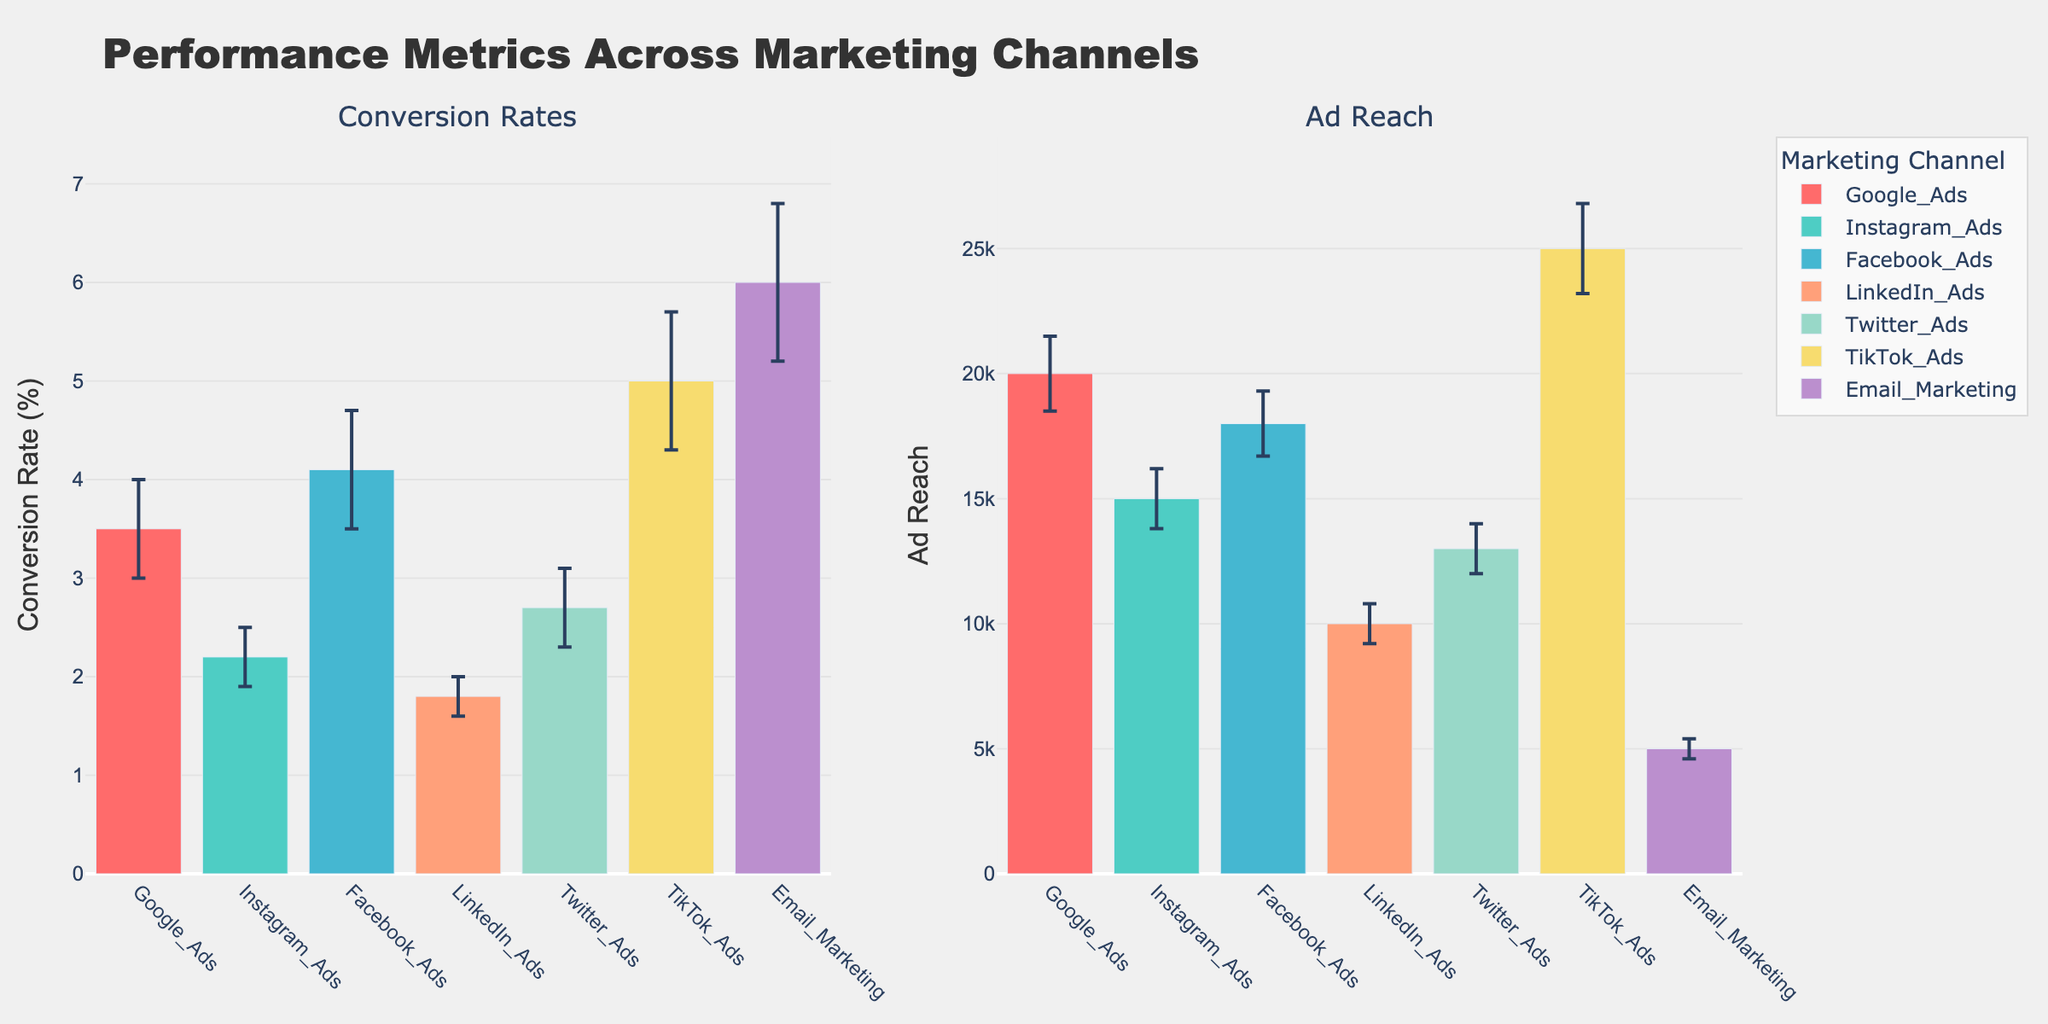What are the titles of the subplots? The subplot titles are at the top of each subplot. The first subplot is titled "Conversion Rates," and the second subplot is titled "Ad Reach."
Answer: "Conversion Rates" and "Ad Reach" Which marketing channel has the highest conversion rate? By looking at the height of the bars in the "Conversion Rates" subplot, the bar for "Email Marketing" is the highest.
Answer: Email Marketing How much higher is TikTok Ads' ad reach compared to LinkedIn Ads' ad reach? TikTok Ads has an ad reach of 25000 with an error margin of 1800, and LinkedIn Ads has an ad reach of 10000 with an error margin of 800. The difference is 25000 - 10000 = 15000.
Answer: 15000 Which marketing channel has the lowest conversion rate? By comparing the heights of all bars in the "Conversion Rates" subplot, LinkedIn Ads has the lowest conversion rate.
Answer: LinkedIn Ads What is the error margin for Instagram Ads' conversion rate? The error margin is represented by the length of the error bar on top of the Instagram Ads bar in the "Conversion Rates" subplot. The error margin is 0.3%.
Answer: 0.3% Between Google Ads and Facebook Ads, which has a better performance in terms of conversion rate? By examining the bars in the "Conversion Rates" subplot, Facebook Ads has a higher conversion rate (4.1%) compared to Google Ads (3.5%).
Answer: Facebook Ads Does any marketing channel have an ad reach below 10,000? By reviewing the "Ad Reach" subplot, Email Marketing has an ad reach below 10,000.
Answer: Yes How does Twitter Ads' conversion rate compare to Instagram Ads' conversion rate? Twitter Ads has a conversion rate of 2.7% with an error margin of 0.4%, while Instagram Ads has a conversion rate of 2.2% with an error margin of 0.3%. Twitter Ads' conversion rate is 0.5% higher than Instagram Ads' conversion rate.
Answer: Twitter Ads is higher On average, which type of metric seems to have more variation among marketing channels: conversion rates or ad reach? By comparing the length of error bars across both subplots, the ad reach subplot generally has longer error bars, indicating more variation.
Answer: Ad reach What is the combined ad reach of Google Ads and Facebook Ads? Google's ad reach is 20000, and Facebook's ad reach is 18000. When combined: 20000 + 18000 = 38000.
Answer: 38000 